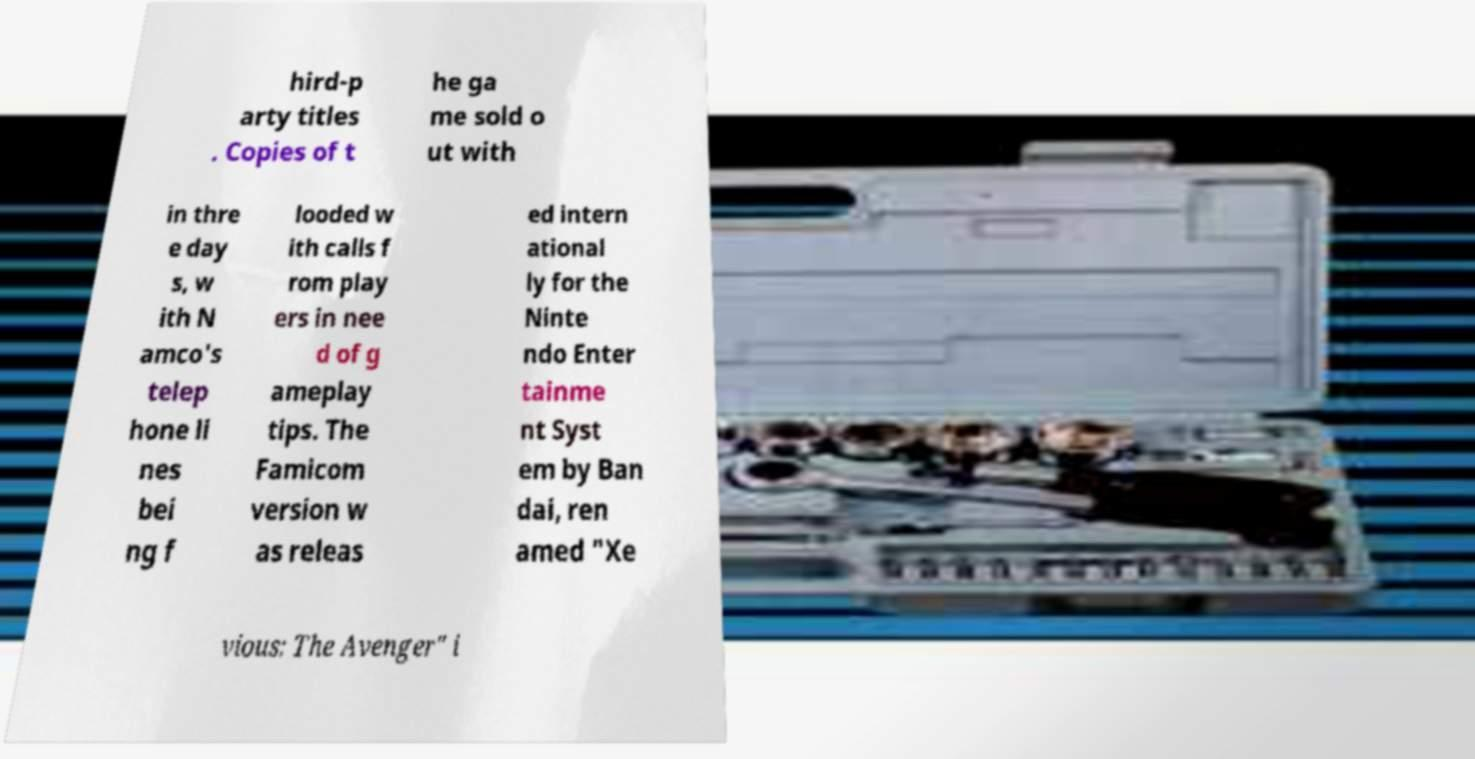Can you read and provide the text displayed in the image?This photo seems to have some interesting text. Can you extract and type it out for me? hird-p arty titles . Copies of t he ga me sold o ut with in thre e day s, w ith N amco's telep hone li nes bei ng f looded w ith calls f rom play ers in nee d of g ameplay tips. The Famicom version w as releas ed intern ational ly for the Ninte ndo Enter tainme nt Syst em by Ban dai, ren amed "Xe vious: The Avenger" i 